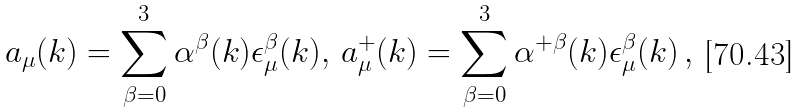Convert formula to latex. <formula><loc_0><loc_0><loc_500><loc_500>a _ { \mu } ( k ) = \sum _ { \beta = 0 } ^ { 3 } \alpha ^ { \beta } ( k ) \epsilon _ { \mu } ^ { \beta } ( k ) , \, a _ { \mu } ^ { + } ( k ) = \sum _ { \beta = 0 } ^ { 3 } \alpha ^ { + \beta } ( k ) \epsilon _ { \mu } ^ { \beta } ( k ) \, ,</formula> 